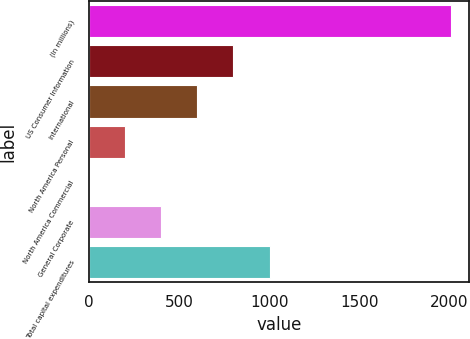Convert chart. <chart><loc_0><loc_0><loc_500><loc_500><bar_chart><fcel>(In millions)<fcel>US Consumer Information<fcel>International<fcel>North America Personal<fcel>North America Commercial<fcel>General Corporate<fcel>Total capital expenditures<nl><fcel>2005<fcel>802.06<fcel>601.57<fcel>200.59<fcel>0.1<fcel>401.08<fcel>1002.55<nl></chart> 